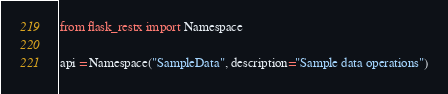<code> <loc_0><loc_0><loc_500><loc_500><_Python_>from flask_restx import Namespace

api = Namespace("SampleData", description="Sample data operations")
</code> 